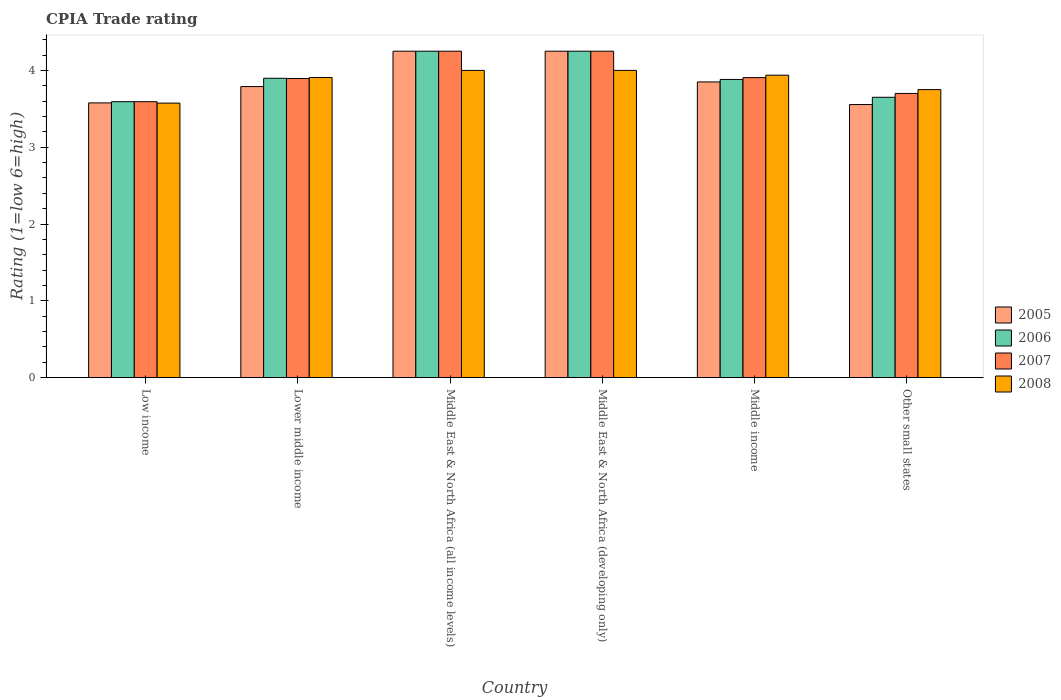How many different coloured bars are there?
Offer a very short reply. 4. Are the number of bars per tick equal to the number of legend labels?
Your response must be concise. Yes. Are the number of bars on each tick of the X-axis equal?
Offer a terse response. Yes. What is the label of the 4th group of bars from the left?
Your answer should be compact. Middle East & North Africa (developing only). In how many cases, is the number of bars for a given country not equal to the number of legend labels?
Offer a terse response. 0. What is the CPIA rating in 2006 in Low income?
Your answer should be compact. 3.59. Across all countries, what is the maximum CPIA rating in 2008?
Your response must be concise. 4. Across all countries, what is the minimum CPIA rating in 2007?
Provide a succinct answer. 3.59. In which country was the CPIA rating in 2008 maximum?
Offer a terse response. Middle East & North Africa (all income levels). In which country was the CPIA rating in 2007 minimum?
Make the answer very short. Low income. What is the total CPIA rating in 2007 in the graph?
Provide a short and direct response. 23.59. What is the difference between the CPIA rating in 2006 in Low income and that in Middle East & North Africa (all income levels)?
Keep it short and to the point. -0.66. What is the difference between the CPIA rating in 2005 in Middle East & North Africa (all income levels) and the CPIA rating in 2006 in Lower middle income?
Your answer should be very brief. 0.35. What is the average CPIA rating in 2007 per country?
Keep it short and to the point. 3.93. What is the difference between the CPIA rating of/in 2005 and CPIA rating of/in 2006 in Middle East & North Africa (all income levels)?
Offer a terse response. 0. What is the ratio of the CPIA rating in 2005 in Lower middle income to that in Middle East & North Africa (all income levels)?
Offer a terse response. 0.89. Is the CPIA rating in 2008 in Low income less than that in Middle income?
Ensure brevity in your answer.  Yes. Is the difference between the CPIA rating in 2005 in Middle East & North Africa (developing only) and Other small states greater than the difference between the CPIA rating in 2006 in Middle East & North Africa (developing only) and Other small states?
Give a very brief answer. Yes. What is the difference between the highest and the second highest CPIA rating in 2005?
Provide a short and direct response. -0.4. What is the difference between the highest and the lowest CPIA rating in 2006?
Ensure brevity in your answer.  0.66. Is the sum of the CPIA rating in 2008 in Lower middle income and Middle East & North Africa (developing only) greater than the maximum CPIA rating in 2006 across all countries?
Offer a terse response. Yes. Is it the case that in every country, the sum of the CPIA rating in 2007 and CPIA rating in 2005 is greater than the sum of CPIA rating in 2008 and CPIA rating in 2006?
Keep it short and to the point. No. Is it the case that in every country, the sum of the CPIA rating in 2005 and CPIA rating in 2007 is greater than the CPIA rating in 2006?
Keep it short and to the point. Yes. How many bars are there?
Give a very brief answer. 24. Are all the bars in the graph horizontal?
Make the answer very short. No. Does the graph contain any zero values?
Keep it short and to the point. No. Does the graph contain grids?
Provide a succinct answer. No. What is the title of the graph?
Keep it short and to the point. CPIA Trade rating. Does "1982" appear as one of the legend labels in the graph?
Make the answer very short. No. What is the label or title of the X-axis?
Provide a short and direct response. Country. What is the Rating (1=low 6=high) in 2005 in Low income?
Keep it short and to the point. 3.58. What is the Rating (1=low 6=high) in 2006 in Low income?
Provide a succinct answer. 3.59. What is the Rating (1=low 6=high) of 2007 in Low income?
Your answer should be very brief. 3.59. What is the Rating (1=low 6=high) in 2008 in Low income?
Make the answer very short. 3.57. What is the Rating (1=low 6=high) of 2005 in Lower middle income?
Your answer should be very brief. 3.79. What is the Rating (1=low 6=high) in 2006 in Lower middle income?
Provide a short and direct response. 3.9. What is the Rating (1=low 6=high) in 2007 in Lower middle income?
Give a very brief answer. 3.89. What is the Rating (1=low 6=high) of 2008 in Lower middle income?
Provide a succinct answer. 3.91. What is the Rating (1=low 6=high) of 2005 in Middle East & North Africa (all income levels)?
Your response must be concise. 4.25. What is the Rating (1=low 6=high) of 2006 in Middle East & North Africa (all income levels)?
Offer a terse response. 4.25. What is the Rating (1=low 6=high) in 2007 in Middle East & North Africa (all income levels)?
Offer a terse response. 4.25. What is the Rating (1=low 6=high) in 2005 in Middle East & North Africa (developing only)?
Your answer should be compact. 4.25. What is the Rating (1=low 6=high) of 2006 in Middle East & North Africa (developing only)?
Your response must be concise. 4.25. What is the Rating (1=low 6=high) of 2007 in Middle East & North Africa (developing only)?
Your answer should be compact. 4.25. What is the Rating (1=low 6=high) of 2008 in Middle East & North Africa (developing only)?
Give a very brief answer. 4. What is the Rating (1=low 6=high) of 2005 in Middle income?
Provide a short and direct response. 3.85. What is the Rating (1=low 6=high) of 2006 in Middle income?
Provide a succinct answer. 3.88. What is the Rating (1=low 6=high) of 2007 in Middle income?
Provide a short and direct response. 3.91. What is the Rating (1=low 6=high) of 2008 in Middle income?
Your answer should be compact. 3.94. What is the Rating (1=low 6=high) in 2005 in Other small states?
Provide a succinct answer. 3.56. What is the Rating (1=low 6=high) in 2006 in Other small states?
Give a very brief answer. 3.65. What is the Rating (1=low 6=high) of 2007 in Other small states?
Your answer should be very brief. 3.7. What is the Rating (1=low 6=high) in 2008 in Other small states?
Your response must be concise. 3.75. Across all countries, what is the maximum Rating (1=low 6=high) in 2005?
Ensure brevity in your answer.  4.25. Across all countries, what is the maximum Rating (1=low 6=high) of 2006?
Provide a short and direct response. 4.25. Across all countries, what is the maximum Rating (1=low 6=high) of 2007?
Provide a short and direct response. 4.25. Across all countries, what is the minimum Rating (1=low 6=high) in 2005?
Your answer should be compact. 3.56. Across all countries, what is the minimum Rating (1=low 6=high) of 2006?
Provide a succinct answer. 3.59. Across all countries, what is the minimum Rating (1=low 6=high) of 2007?
Provide a short and direct response. 3.59. Across all countries, what is the minimum Rating (1=low 6=high) of 2008?
Provide a short and direct response. 3.57. What is the total Rating (1=low 6=high) of 2005 in the graph?
Provide a short and direct response. 23.27. What is the total Rating (1=low 6=high) in 2006 in the graph?
Your answer should be very brief. 23.52. What is the total Rating (1=low 6=high) in 2007 in the graph?
Give a very brief answer. 23.59. What is the total Rating (1=low 6=high) in 2008 in the graph?
Your response must be concise. 23.17. What is the difference between the Rating (1=low 6=high) of 2005 in Low income and that in Lower middle income?
Your answer should be compact. -0.21. What is the difference between the Rating (1=low 6=high) in 2006 in Low income and that in Lower middle income?
Make the answer very short. -0.3. What is the difference between the Rating (1=low 6=high) of 2007 in Low income and that in Lower middle income?
Offer a very short reply. -0.3. What is the difference between the Rating (1=low 6=high) in 2008 in Low income and that in Lower middle income?
Your response must be concise. -0.33. What is the difference between the Rating (1=low 6=high) of 2005 in Low income and that in Middle East & North Africa (all income levels)?
Your answer should be very brief. -0.67. What is the difference between the Rating (1=low 6=high) of 2006 in Low income and that in Middle East & North Africa (all income levels)?
Your response must be concise. -0.66. What is the difference between the Rating (1=low 6=high) of 2007 in Low income and that in Middle East & North Africa (all income levels)?
Your response must be concise. -0.66. What is the difference between the Rating (1=low 6=high) in 2008 in Low income and that in Middle East & North Africa (all income levels)?
Give a very brief answer. -0.43. What is the difference between the Rating (1=low 6=high) in 2005 in Low income and that in Middle East & North Africa (developing only)?
Make the answer very short. -0.67. What is the difference between the Rating (1=low 6=high) of 2006 in Low income and that in Middle East & North Africa (developing only)?
Your response must be concise. -0.66. What is the difference between the Rating (1=low 6=high) of 2007 in Low income and that in Middle East & North Africa (developing only)?
Ensure brevity in your answer.  -0.66. What is the difference between the Rating (1=low 6=high) of 2008 in Low income and that in Middle East & North Africa (developing only)?
Your answer should be compact. -0.43. What is the difference between the Rating (1=low 6=high) in 2005 in Low income and that in Middle income?
Ensure brevity in your answer.  -0.27. What is the difference between the Rating (1=low 6=high) of 2006 in Low income and that in Middle income?
Offer a terse response. -0.29. What is the difference between the Rating (1=low 6=high) of 2007 in Low income and that in Middle income?
Offer a very short reply. -0.31. What is the difference between the Rating (1=low 6=high) of 2008 in Low income and that in Middle income?
Your answer should be compact. -0.36. What is the difference between the Rating (1=low 6=high) of 2005 in Low income and that in Other small states?
Ensure brevity in your answer.  0.02. What is the difference between the Rating (1=low 6=high) in 2006 in Low income and that in Other small states?
Your answer should be compact. -0.06. What is the difference between the Rating (1=low 6=high) in 2007 in Low income and that in Other small states?
Your answer should be very brief. -0.11. What is the difference between the Rating (1=low 6=high) of 2008 in Low income and that in Other small states?
Provide a short and direct response. -0.18. What is the difference between the Rating (1=low 6=high) of 2005 in Lower middle income and that in Middle East & North Africa (all income levels)?
Give a very brief answer. -0.46. What is the difference between the Rating (1=low 6=high) in 2006 in Lower middle income and that in Middle East & North Africa (all income levels)?
Provide a succinct answer. -0.35. What is the difference between the Rating (1=low 6=high) in 2007 in Lower middle income and that in Middle East & North Africa (all income levels)?
Keep it short and to the point. -0.36. What is the difference between the Rating (1=low 6=high) of 2008 in Lower middle income and that in Middle East & North Africa (all income levels)?
Your response must be concise. -0.09. What is the difference between the Rating (1=low 6=high) of 2005 in Lower middle income and that in Middle East & North Africa (developing only)?
Your answer should be compact. -0.46. What is the difference between the Rating (1=low 6=high) in 2006 in Lower middle income and that in Middle East & North Africa (developing only)?
Ensure brevity in your answer.  -0.35. What is the difference between the Rating (1=low 6=high) of 2007 in Lower middle income and that in Middle East & North Africa (developing only)?
Make the answer very short. -0.36. What is the difference between the Rating (1=low 6=high) of 2008 in Lower middle income and that in Middle East & North Africa (developing only)?
Your response must be concise. -0.09. What is the difference between the Rating (1=low 6=high) of 2005 in Lower middle income and that in Middle income?
Your answer should be compact. -0.06. What is the difference between the Rating (1=low 6=high) of 2006 in Lower middle income and that in Middle income?
Your response must be concise. 0.02. What is the difference between the Rating (1=low 6=high) in 2007 in Lower middle income and that in Middle income?
Your response must be concise. -0.01. What is the difference between the Rating (1=low 6=high) of 2008 in Lower middle income and that in Middle income?
Offer a very short reply. -0.03. What is the difference between the Rating (1=low 6=high) in 2005 in Lower middle income and that in Other small states?
Your answer should be very brief. 0.23. What is the difference between the Rating (1=low 6=high) of 2006 in Lower middle income and that in Other small states?
Your answer should be very brief. 0.25. What is the difference between the Rating (1=low 6=high) of 2007 in Lower middle income and that in Other small states?
Provide a succinct answer. 0.19. What is the difference between the Rating (1=low 6=high) in 2008 in Lower middle income and that in Other small states?
Make the answer very short. 0.16. What is the difference between the Rating (1=low 6=high) of 2005 in Middle East & North Africa (all income levels) and that in Middle East & North Africa (developing only)?
Ensure brevity in your answer.  0. What is the difference between the Rating (1=low 6=high) of 2006 in Middle East & North Africa (all income levels) and that in Middle income?
Ensure brevity in your answer.  0.37. What is the difference between the Rating (1=low 6=high) in 2007 in Middle East & North Africa (all income levels) and that in Middle income?
Give a very brief answer. 0.34. What is the difference between the Rating (1=low 6=high) of 2008 in Middle East & North Africa (all income levels) and that in Middle income?
Provide a succinct answer. 0.06. What is the difference between the Rating (1=low 6=high) of 2005 in Middle East & North Africa (all income levels) and that in Other small states?
Your answer should be compact. 0.69. What is the difference between the Rating (1=low 6=high) in 2007 in Middle East & North Africa (all income levels) and that in Other small states?
Provide a succinct answer. 0.55. What is the difference between the Rating (1=low 6=high) of 2008 in Middle East & North Africa (all income levels) and that in Other small states?
Your answer should be compact. 0.25. What is the difference between the Rating (1=low 6=high) in 2006 in Middle East & North Africa (developing only) and that in Middle income?
Your answer should be compact. 0.37. What is the difference between the Rating (1=low 6=high) of 2007 in Middle East & North Africa (developing only) and that in Middle income?
Your answer should be very brief. 0.34. What is the difference between the Rating (1=low 6=high) of 2008 in Middle East & North Africa (developing only) and that in Middle income?
Your answer should be very brief. 0.06. What is the difference between the Rating (1=low 6=high) in 2005 in Middle East & North Africa (developing only) and that in Other small states?
Your answer should be compact. 0.69. What is the difference between the Rating (1=low 6=high) of 2007 in Middle East & North Africa (developing only) and that in Other small states?
Make the answer very short. 0.55. What is the difference between the Rating (1=low 6=high) in 2008 in Middle East & North Africa (developing only) and that in Other small states?
Your answer should be compact. 0.25. What is the difference between the Rating (1=low 6=high) of 2005 in Middle income and that in Other small states?
Offer a terse response. 0.29. What is the difference between the Rating (1=low 6=high) of 2006 in Middle income and that in Other small states?
Your response must be concise. 0.23. What is the difference between the Rating (1=low 6=high) in 2007 in Middle income and that in Other small states?
Give a very brief answer. 0.21. What is the difference between the Rating (1=low 6=high) of 2008 in Middle income and that in Other small states?
Give a very brief answer. 0.19. What is the difference between the Rating (1=low 6=high) in 2005 in Low income and the Rating (1=low 6=high) in 2006 in Lower middle income?
Give a very brief answer. -0.32. What is the difference between the Rating (1=low 6=high) in 2005 in Low income and the Rating (1=low 6=high) in 2007 in Lower middle income?
Give a very brief answer. -0.32. What is the difference between the Rating (1=low 6=high) of 2005 in Low income and the Rating (1=low 6=high) of 2008 in Lower middle income?
Offer a very short reply. -0.33. What is the difference between the Rating (1=low 6=high) in 2006 in Low income and the Rating (1=low 6=high) in 2007 in Lower middle income?
Provide a short and direct response. -0.3. What is the difference between the Rating (1=low 6=high) of 2006 in Low income and the Rating (1=low 6=high) of 2008 in Lower middle income?
Provide a succinct answer. -0.32. What is the difference between the Rating (1=low 6=high) of 2007 in Low income and the Rating (1=low 6=high) of 2008 in Lower middle income?
Provide a short and direct response. -0.32. What is the difference between the Rating (1=low 6=high) of 2005 in Low income and the Rating (1=low 6=high) of 2006 in Middle East & North Africa (all income levels)?
Ensure brevity in your answer.  -0.67. What is the difference between the Rating (1=low 6=high) in 2005 in Low income and the Rating (1=low 6=high) in 2007 in Middle East & North Africa (all income levels)?
Provide a short and direct response. -0.67. What is the difference between the Rating (1=low 6=high) of 2005 in Low income and the Rating (1=low 6=high) of 2008 in Middle East & North Africa (all income levels)?
Your answer should be compact. -0.42. What is the difference between the Rating (1=low 6=high) in 2006 in Low income and the Rating (1=low 6=high) in 2007 in Middle East & North Africa (all income levels)?
Keep it short and to the point. -0.66. What is the difference between the Rating (1=low 6=high) in 2006 in Low income and the Rating (1=low 6=high) in 2008 in Middle East & North Africa (all income levels)?
Offer a very short reply. -0.41. What is the difference between the Rating (1=low 6=high) in 2007 in Low income and the Rating (1=low 6=high) in 2008 in Middle East & North Africa (all income levels)?
Provide a short and direct response. -0.41. What is the difference between the Rating (1=low 6=high) in 2005 in Low income and the Rating (1=low 6=high) in 2006 in Middle East & North Africa (developing only)?
Your answer should be very brief. -0.67. What is the difference between the Rating (1=low 6=high) in 2005 in Low income and the Rating (1=low 6=high) in 2007 in Middle East & North Africa (developing only)?
Offer a very short reply. -0.67. What is the difference between the Rating (1=low 6=high) in 2005 in Low income and the Rating (1=low 6=high) in 2008 in Middle East & North Africa (developing only)?
Make the answer very short. -0.42. What is the difference between the Rating (1=low 6=high) of 2006 in Low income and the Rating (1=low 6=high) of 2007 in Middle East & North Africa (developing only)?
Make the answer very short. -0.66. What is the difference between the Rating (1=low 6=high) of 2006 in Low income and the Rating (1=low 6=high) of 2008 in Middle East & North Africa (developing only)?
Keep it short and to the point. -0.41. What is the difference between the Rating (1=low 6=high) in 2007 in Low income and the Rating (1=low 6=high) in 2008 in Middle East & North Africa (developing only)?
Make the answer very short. -0.41. What is the difference between the Rating (1=low 6=high) of 2005 in Low income and the Rating (1=low 6=high) of 2006 in Middle income?
Your answer should be compact. -0.31. What is the difference between the Rating (1=low 6=high) of 2005 in Low income and the Rating (1=low 6=high) of 2007 in Middle income?
Ensure brevity in your answer.  -0.33. What is the difference between the Rating (1=low 6=high) of 2005 in Low income and the Rating (1=low 6=high) of 2008 in Middle income?
Keep it short and to the point. -0.36. What is the difference between the Rating (1=low 6=high) of 2006 in Low income and the Rating (1=low 6=high) of 2007 in Middle income?
Your answer should be compact. -0.31. What is the difference between the Rating (1=low 6=high) of 2006 in Low income and the Rating (1=low 6=high) of 2008 in Middle income?
Keep it short and to the point. -0.34. What is the difference between the Rating (1=low 6=high) of 2007 in Low income and the Rating (1=low 6=high) of 2008 in Middle income?
Offer a very short reply. -0.34. What is the difference between the Rating (1=low 6=high) in 2005 in Low income and the Rating (1=low 6=high) in 2006 in Other small states?
Give a very brief answer. -0.07. What is the difference between the Rating (1=low 6=high) in 2005 in Low income and the Rating (1=low 6=high) in 2007 in Other small states?
Your answer should be very brief. -0.12. What is the difference between the Rating (1=low 6=high) in 2005 in Low income and the Rating (1=low 6=high) in 2008 in Other small states?
Offer a terse response. -0.17. What is the difference between the Rating (1=low 6=high) of 2006 in Low income and the Rating (1=low 6=high) of 2007 in Other small states?
Your response must be concise. -0.11. What is the difference between the Rating (1=low 6=high) of 2006 in Low income and the Rating (1=low 6=high) of 2008 in Other small states?
Give a very brief answer. -0.16. What is the difference between the Rating (1=low 6=high) in 2007 in Low income and the Rating (1=low 6=high) in 2008 in Other small states?
Provide a short and direct response. -0.16. What is the difference between the Rating (1=low 6=high) in 2005 in Lower middle income and the Rating (1=low 6=high) in 2006 in Middle East & North Africa (all income levels)?
Your answer should be compact. -0.46. What is the difference between the Rating (1=low 6=high) in 2005 in Lower middle income and the Rating (1=low 6=high) in 2007 in Middle East & North Africa (all income levels)?
Offer a terse response. -0.46. What is the difference between the Rating (1=low 6=high) of 2005 in Lower middle income and the Rating (1=low 6=high) of 2008 in Middle East & North Africa (all income levels)?
Make the answer very short. -0.21. What is the difference between the Rating (1=low 6=high) of 2006 in Lower middle income and the Rating (1=low 6=high) of 2007 in Middle East & North Africa (all income levels)?
Offer a terse response. -0.35. What is the difference between the Rating (1=low 6=high) of 2006 in Lower middle income and the Rating (1=low 6=high) of 2008 in Middle East & North Africa (all income levels)?
Make the answer very short. -0.1. What is the difference between the Rating (1=low 6=high) of 2007 in Lower middle income and the Rating (1=low 6=high) of 2008 in Middle East & North Africa (all income levels)?
Ensure brevity in your answer.  -0.11. What is the difference between the Rating (1=low 6=high) of 2005 in Lower middle income and the Rating (1=low 6=high) of 2006 in Middle East & North Africa (developing only)?
Give a very brief answer. -0.46. What is the difference between the Rating (1=low 6=high) in 2005 in Lower middle income and the Rating (1=low 6=high) in 2007 in Middle East & North Africa (developing only)?
Provide a succinct answer. -0.46. What is the difference between the Rating (1=low 6=high) of 2005 in Lower middle income and the Rating (1=low 6=high) of 2008 in Middle East & North Africa (developing only)?
Your answer should be very brief. -0.21. What is the difference between the Rating (1=low 6=high) of 2006 in Lower middle income and the Rating (1=low 6=high) of 2007 in Middle East & North Africa (developing only)?
Your response must be concise. -0.35. What is the difference between the Rating (1=low 6=high) of 2006 in Lower middle income and the Rating (1=low 6=high) of 2008 in Middle East & North Africa (developing only)?
Make the answer very short. -0.1. What is the difference between the Rating (1=low 6=high) in 2007 in Lower middle income and the Rating (1=low 6=high) in 2008 in Middle East & North Africa (developing only)?
Ensure brevity in your answer.  -0.11. What is the difference between the Rating (1=low 6=high) of 2005 in Lower middle income and the Rating (1=low 6=high) of 2006 in Middle income?
Provide a succinct answer. -0.09. What is the difference between the Rating (1=low 6=high) in 2005 in Lower middle income and the Rating (1=low 6=high) in 2007 in Middle income?
Your answer should be compact. -0.12. What is the difference between the Rating (1=low 6=high) of 2005 in Lower middle income and the Rating (1=low 6=high) of 2008 in Middle income?
Give a very brief answer. -0.15. What is the difference between the Rating (1=low 6=high) in 2006 in Lower middle income and the Rating (1=low 6=high) in 2007 in Middle income?
Your response must be concise. -0.01. What is the difference between the Rating (1=low 6=high) in 2006 in Lower middle income and the Rating (1=low 6=high) in 2008 in Middle income?
Give a very brief answer. -0.04. What is the difference between the Rating (1=low 6=high) of 2007 in Lower middle income and the Rating (1=low 6=high) of 2008 in Middle income?
Keep it short and to the point. -0.04. What is the difference between the Rating (1=low 6=high) of 2005 in Lower middle income and the Rating (1=low 6=high) of 2006 in Other small states?
Offer a terse response. 0.14. What is the difference between the Rating (1=low 6=high) in 2005 in Lower middle income and the Rating (1=low 6=high) in 2007 in Other small states?
Keep it short and to the point. 0.09. What is the difference between the Rating (1=low 6=high) in 2005 in Lower middle income and the Rating (1=low 6=high) in 2008 in Other small states?
Your response must be concise. 0.04. What is the difference between the Rating (1=low 6=high) of 2006 in Lower middle income and the Rating (1=low 6=high) of 2007 in Other small states?
Your answer should be very brief. 0.2. What is the difference between the Rating (1=low 6=high) of 2006 in Lower middle income and the Rating (1=low 6=high) of 2008 in Other small states?
Provide a short and direct response. 0.15. What is the difference between the Rating (1=low 6=high) of 2007 in Lower middle income and the Rating (1=low 6=high) of 2008 in Other small states?
Your answer should be compact. 0.14. What is the difference between the Rating (1=low 6=high) in 2005 in Middle East & North Africa (all income levels) and the Rating (1=low 6=high) in 2006 in Middle East & North Africa (developing only)?
Your answer should be very brief. 0. What is the difference between the Rating (1=low 6=high) in 2005 in Middle East & North Africa (all income levels) and the Rating (1=low 6=high) in 2007 in Middle East & North Africa (developing only)?
Give a very brief answer. 0. What is the difference between the Rating (1=low 6=high) in 2005 in Middle East & North Africa (all income levels) and the Rating (1=low 6=high) in 2008 in Middle East & North Africa (developing only)?
Provide a short and direct response. 0.25. What is the difference between the Rating (1=low 6=high) in 2006 in Middle East & North Africa (all income levels) and the Rating (1=low 6=high) in 2008 in Middle East & North Africa (developing only)?
Make the answer very short. 0.25. What is the difference between the Rating (1=low 6=high) in 2007 in Middle East & North Africa (all income levels) and the Rating (1=low 6=high) in 2008 in Middle East & North Africa (developing only)?
Your answer should be compact. 0.25. What is the difference between the Rating (1=low 6=high) in 2005 in Middle East & North Africa (all income levels) and the Rating (1=low 6=high) in 2006 in Middle income?
Keep it short and to the point. 0.37. What is the difference between the Rating (1=low 6=high) in 2005 in Middle East & North Africa (all income levels) and the Rating (1=low 6=high) in 2007 in Middle income?
Offer a terse response. 0.34. What is the difference between the Rating (1=low 6=high) in 2005 in Middle East & North Africa (all income levels) and the Rating (1=low 6=high) in 2008 in Middle income?
Ensure brevity in your answer.  0.31. What is the difference between the Rating (1=low 6=high) of 2006 in Middle East & North Africa (all income levels) and the Rating (1=low 6=high) of 2007 in Middle income?
Give a very brief answer. 0.34. What is the difference between the Rating (1=low 6=high) of 2006 in Middle East & North Africa (all income levels) and the Rating (1=low 6=high) of 2008 in Middle income?
Provide a short and direct response. 0.31. What is the difference between the Rating (1=low 6=high) in 2007 in Middle East & North Africa (all income levels) and the Rating (1=low 6=high) in 2008 in Middle income?
Your answer should be compact. 0.31. What is the difference between the Rating (1=low 6=high) of 2005 in Middle East & North Africa (all income levels) and the Rating (1=low 6=high) of 2006 in Other small states?
Make the answer very short. 0.6. What is the difference between the Rating (1=low 6=high) in 2005 in Middle East & North Africa (all income levels) and the Rating (1=low 6=high) in 2007 in Other small states?
Offer a terse response. 0.55. What is the difference between the Rating (1=low 6=high) in 2005 in Middle East & North Africa (all income levels) and the Rating (1=low 6=high) in 2008 in Other small states?
Make the answer very short. 0.5. What is the difference between the Rating (1=low 6=high) in 2006 in Middle East & North Africa (all income levels) and the Rating (1=low 6=high) in 2007 in Other small states?
Keep it short and to the point. 0.55. What is the difference between the Rating (1=low 6=high) of 2007 in Middle East & North Africa (all income levels) and the Rating (1=low 6=high) of 2008 in Other small states?
Your answer should be compact. 0.5. What is the difference between the Rating (1=low 6=high) of 2005 in Middle East & North Africa (developing only) and the Rating (1=low 6=high) of 2006 in Middle income?
Give a very brief answer. 0.37. What is the difference between the Rating (1=low 6=high) of 2005 in Middle East & North Africa (developing only) and the Rating (1=low 6=high) of 2007 in Middle income?
Your response must be concise. 0.34. What is the difference between the Rating (1=low 6=high) of 2005 in Middle East & North Africa (developing only) and the Rating (1=low 6=high) of 2008 in Middle income?
Make the answer very short. 0.31. What is the difference between the Rating (1=low 6=high) of 2006 in Middle East & North Africa (developing only) and the Rating (1=low 6=high) of 2007 in Middle income?
Keep it short and to the point. 0.34. What is the difference between the Rating (1=low 6=high) in 2006 in Middle East & North Africa (developing only) and the Rating (1=low 6=high) in 2008 in Middle income?
Make the answer very short. 0.31. What is the difference between the Rating (1=low 6=high) of 2007 in Middle East & North Africa (developing only) and the Rating (1=low 6=high) of 2008 in Middle income?
Ensure brevity in your answer.  0.31. What is the difference between the Rating (1=low 6=high) in 2005 in Middle East & North Africa (developing only) and the Rating (1=low 6=high) in 2006 in Other small states?
Your response must be concise. 0.6. What is the difference between the Rating (1=low 6=high) of 2005 in Middle East & North Africa (developing only) and the Rating (1=low 6=high) of 2007 in Other small states?
Ensure brevity in your answer.  0.55. What is the difference between the Rating (1=low 6=high) of 2006 in Middle East & North Africa (developing only) and the Rating (1=low 6=high) of 2007 in Other small states?
Give a very brief answer. 0.55. What is the difference between the Rating (1=low 6=high) in 2007 in Middle East & North Africa (developing only) and the Rating (1=low 6=high) in 2008 in Other small states?
Your response must be concise. 0.5. What is the difference between the Rating (1=low 6=high) of 2005 in Middle income and the Rating (1=low 6=high) of 2006 in Other small states?
Provide a succinct answer. 0.2. What is the difference between the Rating (1=low 6=high) in 2005 in Middle income and the Rating (1=low 6=high) in 2008 in Other small states?
Your answer should be compact. 0.1. What is the difference between the Rating (1=low 6=high) in 2006 in Middle income and the Rating (1=low 6=high) in 2007 in Other small states?
Provide a succinct answer. 0.18. What is the difference between the Rating (1=low 6=high) of 2006 in Middle income and the Rating (1=low 6=high) of 2008 in Other small states?
Offer a terse response. 0.13. What is the difference between the Rating (1=low 6=high) of 2007 in Middle income and the Rating (1=low 6=high) of 2008 in Other small states?
Offer a very short reply. 0.16. What is the average Rating (1=low 6=high) of 2005 per country?
Ensure brevity in your answer.  3.88. What is the average Rating (1=low 6=high) in 2006 per country?
Your response must be concise. 3.92. What is the average Rating (1=low 6=high) in 2007 per country?
Ensure brevity in your answer.  3.93. What is the average Rating (1=low 6=high) in 2008 per country?
Your response must be concise. 3.86. What is the difference between the Rating (1=low 6=high) of 2005 and Rating (1=low 6=high) of 2006 in Low income?
Your answer should be compact. -0.02. What is the difference between the Rating (1=low 6=high) of 2005 and Rating (1=low 6=high) of 2007 in Low income?
Your response must be concise. -0.02. What is the difference between the Rating (1=low 6=high) in 2005 and Rating (1=low 6=high) in 2008 in Low income?
Ensure brevity in your answer.  0. What is the difference between the Rating (1=low 6=high) in 2006 and Rating (1=low 6=high) in 2008 in Low income?
Ensure brevity in your answer.  0.02. What is the difference between the Rating (1=low 6=high) in 2007 and Rating (1=low 6=high) in 2008 in Low income?
Offer a terse response. 0.02. What is the difference between the Rating (1=low 6=high) of 2005 and Rating (1=low 6=high) of 2006 in Lower middle income?
Make the answer very short. -0.11. What is the difference between the Rating (1=low 6=high) of 2005 and Rating (1=low 6=high) of 2007 in Lower middle income?
Make the answer very short. -0.11. What is the difference between the Rating (1=low 6=high) of 2005 and Rating (1=low 6=high) of 2008 in Lower middle income?
Your answer should be compact. -0.12. What is the difference between the Rating (1=low 6=high) in 2006 and Rating (1=low 6=high) in 2007 in Lower middle income?
Ensure brevity in your answer.  0. What is the difference between the Rating (1=low 6=high) of 2006 and Rating (1=low 6=high) of 2008 in Lower middle income?
Provide a short and direct response. -0.01. What is the difference between the Rating (1=low 6=high) in 2007 and Rating (1=low 6=high) in 2008 in Lower middle income?
Keep it short and to the point. -0.01. What is the difference between the Rating (1=low 6=high) in 2005 and Rating (1=low 6=high) in 2006 in Middle East & North Africa (all income levels)?
Ensure brevity in your answer.  0. What is the difference between the Rating (1=low 6=high) in 2006 and Rating (1=low 6=high) in 2008 in Middle East & North Africa (all income levels)?
Keep it short and to the point. 0.25. What is the difference between the Rating (1=low 6=high) of 2007 and Rating (1=low 6=high) of 2008 in Middle East & North Africa (all income levels)?
Your answer should be compact. 0.25. What is the difference between the Rating (1=low 6=high) of 2005 and Rating (1=low 6=high) of 2006 in Middle East & North Africa (developing only)?
Your answer should be very brief. 0. What is the difference between the Rating (1=low 6=high) of 2005 and Rating (1=low 6=high) of 2008 in Middle East & North Africa (developing only)?
Your answer should be very brief. 0.25. What is the difference between the Rating (1=low 6=high) of 2007 and Rating (1=low 6=high) of 2008 in Middle East & North Africa (developing only)?
Provide a short and direct response. 0.25. What is the difference between the Rating (1=low 6=high) in 2005 and Rating (1=low 6=high) in 2006 in Middle income?
Your response must be concise. -0.03. What is the difference between the Rating (1=low 6=high) in 2005 and Rating (1=low 6=high) in 2007 in Middle income?
Provide a succinct answer. -0.06. What is the difference between the Rating (1=low 6=high) in 2005 and Rating (1=low 6=high) in 2008 in Middle income?
Make the answer very short. -0.09. What is the difference between the Rating (1=low 6=high) in 2006 and Rating (1=low 6=high) in 2007 in Middle income?
Ensure brevity in your answer.  -0.02. What is the difference between the Rating (1=low 6=high) of 2006 and Rating (1=low 6=high) of 2008 in Middle income?
Your answer should be very brief. -0.06. What is the difference between the Rating (1=low 6=high) of 2007 and Rating (1=low 6=high) of 2008 in Middle income?
Make the answer very short. -0.03. What is the difference between the Rating (1=low 6=high) of 2005 and Rating (1=low 6=high) of 2006 in Other small states?
Offer a terse response. -0.09. What is the difference between the Rating (1=low 6=high) of 2005 and Rating (1=low 6=high) of 2007 in Other small states?
Your answer should be compact. -0.14. What is the difference between the Rating (1=low 6=high) in 2005 and Rating (1=low 6=high) in 2008 in Other small states?
Make the answer very short. -0.19. What is the difference between the Rating (1=low 6=high) of 2006 and Rating (1=low 6=high) of 2008 in Other small states?
Offer a very short reply. -0.1. What is the ratio of the Rating (1=low 6=high) of 2005 in Low income to that in Lower middle income?
Your answer should be compact. 0.94. What is the ratio of the Rating (1=low 6=high) in 2006 in Low income to that in Lower middle income?
Offer a very short reply. 0.92. What is the ratio of the Rating (1=low 6=high) in 2007 in Low income to that in Lower middle income?
Give a very brief answer. 0.92. What is the ratio of the Rating (1=low 6=high) in 2008 in Low income to that in Lower middle income?
Make the answer very short. 0.91. What is the ratio of the Rating (1=low 6=high) of 2005 in Low income to that in Middle East & North Africa (all income levels)?
Provide a short and direct response. 0.84. What is the ratio of the Rating (1=low 6=high) of 2006 in Low income to that in Middle East & North Africa (all income levels)?
Provide a succinct answer. 0.85. What is the ratio of the Rating (1=low 6=high) of 2007 in Low income to that in Middle East & North Africa (all income levels)?
Keep it short and to the point. 0.85. What is the ratio of the Rating (1=low 6=high) of 2008 in Low income to that in Middle East & North Africa (all income levels)?
Give a very brief answer. 0.89. What is the ratio of the Rating (1=low 6=high) of 2005 in Low income to that in Middle East & North Africa (developing only)?
Make the answer very short. 0.84. What is the ratio of the Rating (1=low 6=high) of 2006 in Low income to that in Middle East & North Africa (developing only)?
Offer a terse response. 0.85. What is the ratio of the Rating (1=low 6=high) of 2007 in Low income to that in Middle East & North Africa (developing only)?
Your response must be concise. 0.85. What is the ratio of the Rating (1=low 6=high) of 2008 in Low income to that in Middle East & North Africa (developing only)?
Offer a very short reply. 0.89. What is the ratio of the Rating (1=low 6=high) of 2005 in Low income to that in Middle income?
Offer a very short reply. 0.93. What is the ratio of the Rating (1=low 6=high) of 2006 in Low income to that in Middle income?
Offer a terse response. 0.93. What is the ratio of the Rating (1=low 6=high) in 2007 in Low income to that in Middle income?
Provide a short and direct response. 0.92. What is the ratio of the Rating (1=low 6=high) in 2008 in Low income to that in Middle income?
Offer a very short reply. 0.91. What is the ratio of the Rating (1=low 6=high) of 2006 in Low income to that in Other small states?
Your answer should be very brief. 0.98. What is the ratio of the Rating (1=low 6=high) of 2007 in Low income to that in Other small states?
Make the answer very short. 0.97. What is the ratio of the Rating (1=low 6=high) of 2008 in Low income to that in Other small states?
Provide a short and direct response. 0.95. What is the ratio of the Rating (1=low 6=high) of 2005 in Lower middle income to that in Middle East & North Africa (all income levels)?
Offer a very short reply. 0.89. What is the ratio of the Rating (1=low 6=high) of 2006 in Lower middle income to that in Middle East & North Africa (all income levels)?
Provide a succinct answer. 0.92. What is the ratio of the Rating (1=low 6=high) of 2007 in Lower middle income to that in Middle East & North Africa (all income levels)?
Provide a succinct answer. 0.92. What is the ratio of the Rating (1=low 6=high) of 2005 in Lower middle income to that in Middle East & North Africa (developing only)?
Your answer should be very brief. 0.89. What is the ratio of the Rating (1=low 6=high) of 2006 in Lower middle income to that in Middle East & North Africa (developing only)?
Provide a short and direct response. 0.92. What is the ratio of the Rating (1=low 6=high) of 2007 in Lower middle income to that in Middle East & North Africa (developing only)?
Keep it short and to the point. 0.92. What is the ratio of the Rating (1=low 6=high) in 2008 in Lower middle income to that in Middle East & North Africa (developing only)?
Give a very brief answer. 0.98. What is the ratio of the Rating (1=low 6=high) of 2005 in Lower middle income to that in Middle income?
Your response must be concise. 0.98. What is the ratio of the Rating (1=low 6=high) in 2007 in Lower middle income to that in Middle income?
Your answer should be very brief. 1. What is the ratio of the Rating (1=low 6=high) of 2005 in Lower middle income to that in Other small states?
Your answer should be compact. 1.07. What is the ratio of the Rating (1=low 6=high) of 2006 in Lower middle income to that in Other small states?
Offer a very short reply. 1.07. What is the ratio of the Rating (1=low 6=high) in 2007 in Lower middle income to that in Other small states?
Your answer should be very brief. 1.05. What is the ratio of the Rating (1=low 6=high) of 2008 in Lower middle income to that in Other small states?
Make the answer very short. 1.04. What is the ratio of the Rating (1=low 6=high) of 2005 in Middle East & North Africa (all income levels) to that in Middle East & North Africa (developing only)?
Offer a terse response. 1. What is the ratio of the Rating (1=low 6=high) of 2006 in Middle East & North Africa (all income levels) to that in Middle East & North Africa (developing only)?
Make the answer very short. 1. What is the ratio of the Rating (1=low 6=high) of 2007 in Middle East & North Africa (all income levels) to that in Middle East & North Africa (developing only)?
Provide a short and direct response. 1. What is the ratio of the Rating (1=low 6=high) in 2008 in Middle East & North Africa (all income levels) to that in Middle East & North Africa (developing only)?
Ensure brevity in your answer.  1. What is the ratio of the Rating (1=low 6=high) of 2005 in Middle East & North Africa (all income levels) to that in Middle income?
Your answer should be compact. 1.1. What is the ratio of the Rating (1=low 6=high) of 2006 in Middle East & North Africa (all income levels) to that in Middle income?
Your answer should be compact. 1.09. What is the ratio of the Rating (1=low 6=high) in 2007 in Middle East & North Africa (all income levels) to that in Middle income?
Give a very brief answer. 1.09. What is the ratio of the Rating (1=low 6=high) of 2008 in Middle East & North Africa (all income levels) to that in Middle income?
Make the answer very short. 1.02. What is the ratio of the Rating (1=low 6=high) in 2005 in Middle East & North Africa (all income levels) to that in Other small states?
Offer a very short reply. 1.2. What is the ratio of the Rating (1=low 6=high) in 2006 in Middle East & North Africa (all income levels) to that in Other small states?
Provide a succinct answer. 1.16. What is the ratio of the Rating (1=low 6=high) in 2007 in Middle East & North Africa (all income levels) to that in Other small states?
Keep it short and to the point. 1.15. What is the ratio of the Rating (1=low 6=high) in 2008 in Middle East & North Africa (all income levels) to that in Other small states?
Your answer should be compact. 1.07. What is the ratio of the Rating (1=low 6=high) of 2005 in Middle East & North Africa (developing only) to that in Middle income?
Your response must be concise. 1.1. What is the ratio of the Rating (1=low 6=high) of 2006 in Middle East & North Africa (developing only) to that in Middle income?
Your response must be concise. 1.09. What is the ratio of the Rating (1=low 6=high) of 2007 in Middle East & North Africa (developing only) to that in Middle income?
Ensure brevity in your answer.  1.09. What is the ratio of the Rating (1=low 6=high) of 2008 in Middle East & North Africa (developing only) to that in Middle income?
Your response must be concise. 1.02. What is the ratio of the Rating (1=low 6=high) of 2005 in Middle East & North Africa (developing only) to that in Other small states?
Provide a short and direct response. 1.2. What is the ratio of the Rating (1=low 6=high) of 2006 in Middle East & North Africa (developing only) to that in Other small states?
Offer a terse response. 1.16. What is the ratio of the Rating (1=low 6=high) in 2007 in Middle East & North Africa (developing only) to that in Other small states?
Provide a succinct answer. 1.15. What is the ratio of the Rating (1=low 6=high) in 2008 in Middle East & North Africa (developing only) to that in Other small states?
Give a very brief answer. 1.07. What is the ratio of the Rating (1=low 6=high) in 2005 in Middle income to that in Other small states?
Your answer should be compact. 1.08. What is the ratio of the Rating (1=low 6=high) in 2006 in Middle income to that in Other small states?
Offer a very short reply. 1.06. What is the ratio of the Rating (1=low 6=high) in 2007 in Middle income to that in Other small states?
Your answer should be compact. 1.06. What is the difference between the highest and the second highest Rating (1=low 6=high) in 2005?
Provide a short and direct response. 0. What is the difference between the highest and the second highest Rating (1=low 6=high) in 2006?
Provide a succinct answer. 0. What is the difference between the highest and the second highest Rating (1=low 6=high) in 2008?
Offer a terse response. 0. What is the difference between the highest and the lowest Rating (1=low 6=high) of 2005?
Your answer should be compact. 0.69. What is the difference between the highest and the lowest Rating (1=low 6=high) in 2006?
Provide a short and direct response. 0.66. What is the difference between the highest and the lowest Rating (1=low 6=high) in 2007?
Your answer should be very brief. 0.66. What is the difference between the highest and the lowest Rating (1=low 6=high) in 2008?
Keep it short and to the point. 0.43. 